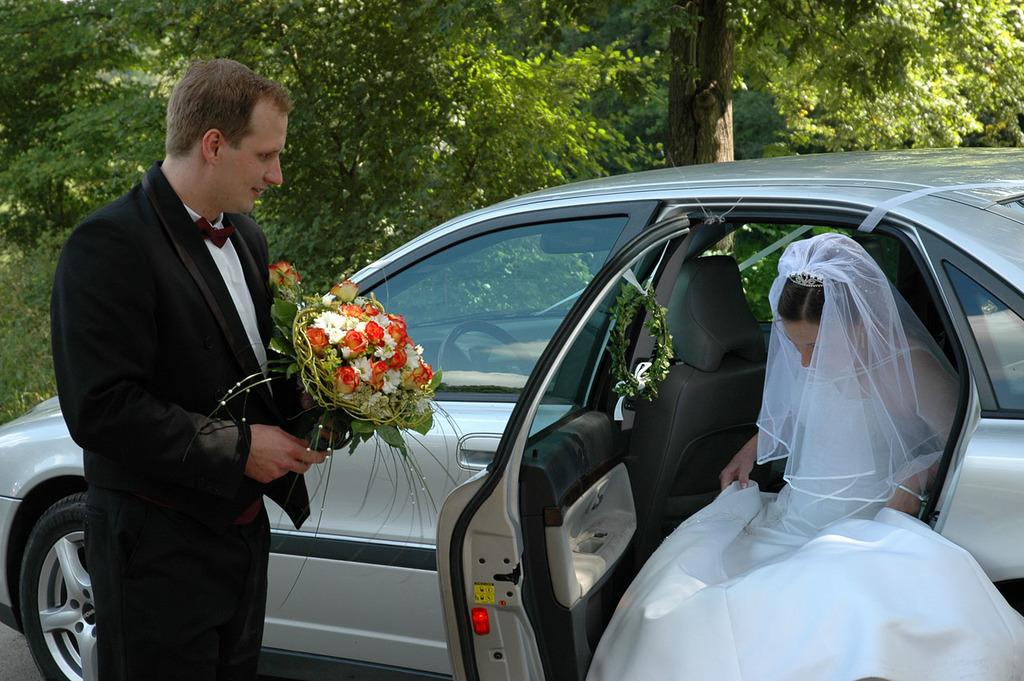What is the man in the image wearing? The man is wearing a black blazer. What is the man holding in the image? The man is holding a bouquet. What is the woman in the image wearing? The woman is wearing a white dress. What is the woman doing in the image? The woman is getting down from a car. What can be seen in the background of the image? There are trees in the background of the image. What type of jewel is the man shaking in the image? There is no jewel present in the image, nor is the man shaking anything. 